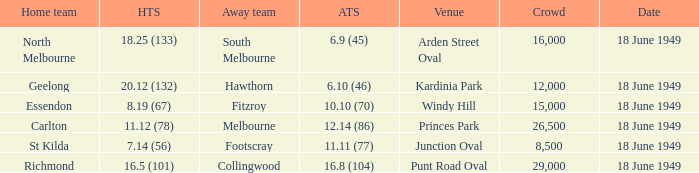What is the away team score when home team score is 20.12 (132)? 6.10 (46). 